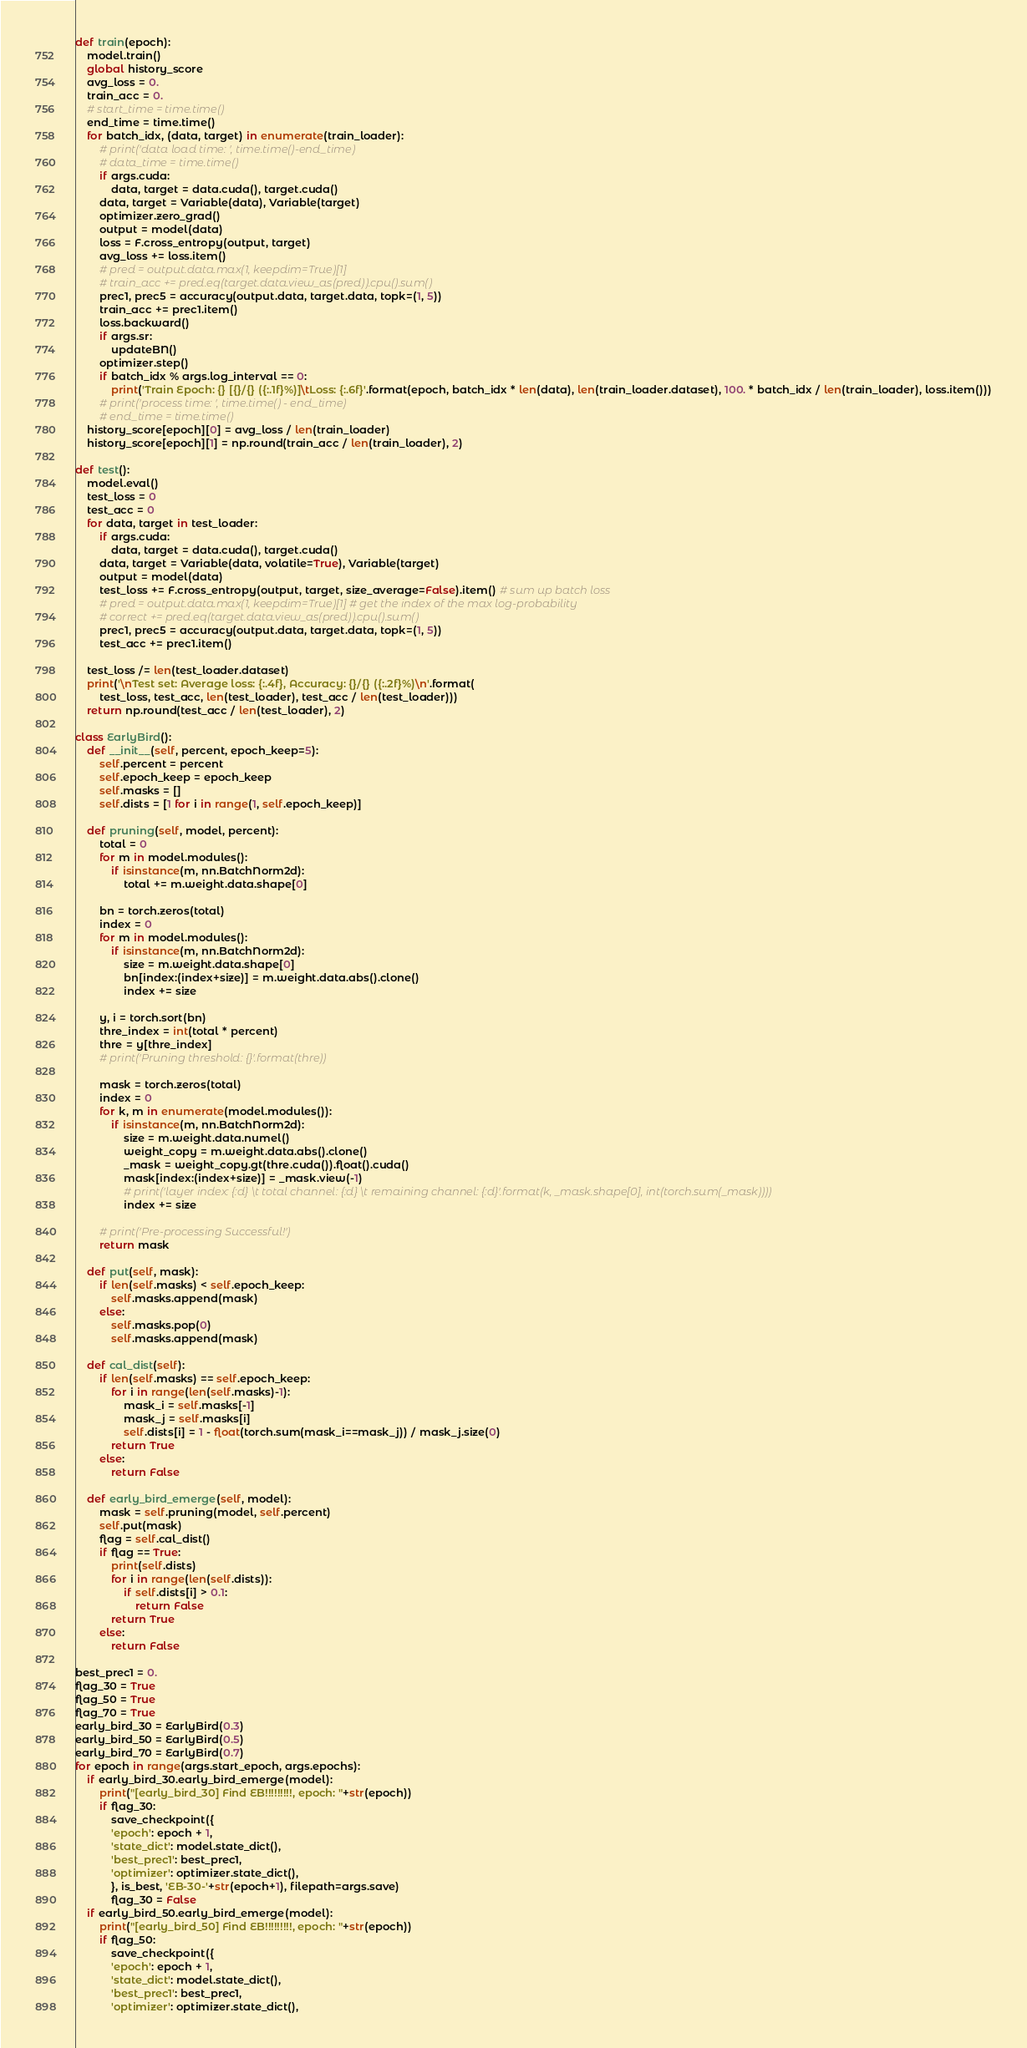<code> <loc_0><loc_0><loc_500><loc_500><_Python_>
def train(epoch):
    model.train()
    global history_score
    avg_loss = 0.
    train_acc = 0.
    # start_time = time.time()
    end_time = time.time()
    for batch_idx, (data, target) in enumerate(train_loader):
        # print('data load time: ', time.time()-end_time)
        # data_time = time.time()
        if args.cuda:
            data, target = data.cuda(), target.cuda()
        data, target = Variable(data), Variable(target)
        optimizer.zero_grad()
        output = model(data)
        loss = F.cross_entropy(output, target)
        avg_loss += loss.item()
        # pred = output.data.max(1, keepdim=True)[1]
        # train_acc += pred.eq(target.data.view_as(pred)).cpu().sum()
        prec1, prec5 = accuracy(output.data, target.data, topk=(1, 5))
        train_acc += prec1.item()
        loss.backward()
        if args.sr:
            updateBN()
        optimizer.step()
        if batch_idx % args.log_interval == 0:
            print('Train Epoch: {} [{}/{} ({:.1f}%)]\tLoss: {:.6f}'.format(epoch, batch_idx * len(data), len(train_loader.dataset), 100. * batch_idx / len(train_loader), loss.item()))
        # print('process time: ', time.time() - end_time)
        # end_time = time.time()
    history_score[epoch][0] = avg_loss / len(train_loader)
    history_score[epoch][1] = np.round(train_acc / len(train_loader), 2)

def test():
    model.eval()
    test_loss = 0
    test_acc = 0
    for data, target in test_loader:
        if args.cuda:
            data, target = data.cuda(), target.cuda()
        data, target = Variable(data, volatile=True), Variable(target)
        output = model(data)
        test_loss += F.cross_entropy(output, target, size_average=False).item() # sum up batch loss
        # pred = output.data.max(1, keepdim=True)[1] # get the index of the max log-probability
        # correct += pred.eq(target.data.view_as(pred)).cpu().sum()
        prec1, prec5 = accuracy(output.data, target.data, topk=(1, 5))
        test_acc += prec1.item()

    test_loss /= len(test_loader.dataset)
    print('\nTest set: Average loss: {:.4f}, Accuracy: {}/{} ({:.2f}%)\n'.format(
        test_loss, test_acc, len(test_loader), test_acc / len(test_loader)))
    return np.round(test_acc / len(test_loader), 2)

class EarlyBird():
    def __init__(self, percent, epoch_keep=5):
        self.percent = percent
        self.epoch_keep = epoch_keep
        self.masks = []
        self.dists = [1 for i in range(1, self.epoch_keep)]

    def pruning(self, model, percent):
        total = 0
        for m in model.modules():
            if isinstance(m, nn.BatchNorm2d):
                total += m.weight.data.shape[0]

        bn = torch.zeros(total)
        index = 0
        for m in model.modules():
            if isinstance(m, nn.BatchNorm2d):
                size = m.weight.data.shape[0]
                bn[index:(index+size)] = m.weight.data.abs().clone()
                index += size

        y, i = torch.sort(bn)
        thre_index = int(total * percent)
        thre = y[thre_index]
        # print('Pruning threshold: {}'.format(thre))

        mask = torch.zeros(total)
        index = 0
        for k, m in enumerate(model.modules()):
            if isinstance(m, nn.BatchNorm2d):
                size = m.weight.data.numel()
                weight_copy = m.weight.data.abs().clone()
                _mask = weight_copy.gt(thre.cuda()).float().cuda()
                mask[index:(index+size)] = _mask.view(-1)
                # print('layer index: {:d} \t total channel: {:d} \t remaining channel: {:d}'.format(k, _mask.shape[0], int(torch.sum(_mask))))
                index += size

        # print('Pre-processing Successful!')
        return mask

    def put(self, mask):
        if len(self.masks) < self.epoch_keep:
            self.masks.append(mask)
        else:
            self.masks.pop(0)
            self.masks.append(mask)

    def cal_dist(self):
        if len(self.masks) == self.epoch_keep:
            for i in range(len(self.masks)-1):
                mask_i = self.masks[-1]
                mask_j = self.masks[i]
                self.dists[i] = 1 - float(torch.sum(mask_i==mask_j)) / mask_j.size(0)
            return True
        else:
            return False

    def early_bird_emerge(self, model):
        mask = self.pruning(model, self.percent)
        self.put(mask)
        flag = self.cal_dist()
        if flag == True:
            print(self.dists)
            for i in range(len(self.dists)):
                if self.dists[i] > 0.1:
                    return False
            return True
        else:
            return False

best_prec1 = 0.
flag_30 = True
flag_50 = True
flag_70 = True
early_bird_30 = EarlyBird(0.3)
early_bird_50 = EarlyBird(0.5)
early_bird_70 = EarlyBird(0.7)
for epoch in range(args.start_epoch, args.epochs):
    if early_bird_30.early_bird_emerge(model):
        print("[early_bird_30] Find EB!!!!!!!!!, epoch: "+str(epoch))
        if flag_30:
            save_checkpoint({
            'epoch': epoch + 1,
            'state_dict': model.state_dict(),
            'best_prec1': best_prec1,
            'optimizer': optimizer.state_dict(),
            }, is_best, 'EB-30-'+str(epoch+1), filepath=args.save)
            flag_30 = False
    if early_bird_50.early_bird_emerge(model):
        print("[early_bird_50] Find EB!!!!!!!!!, epoch: "+str(epoch))
        if flag_50:
            save_checkpoint({
            'epoch': epoch + 1,
            'state_dict': model.state_dict(),
            'best_prec1': best_prec1,
            'optimizer': optimizer.state_dict(),</code> 